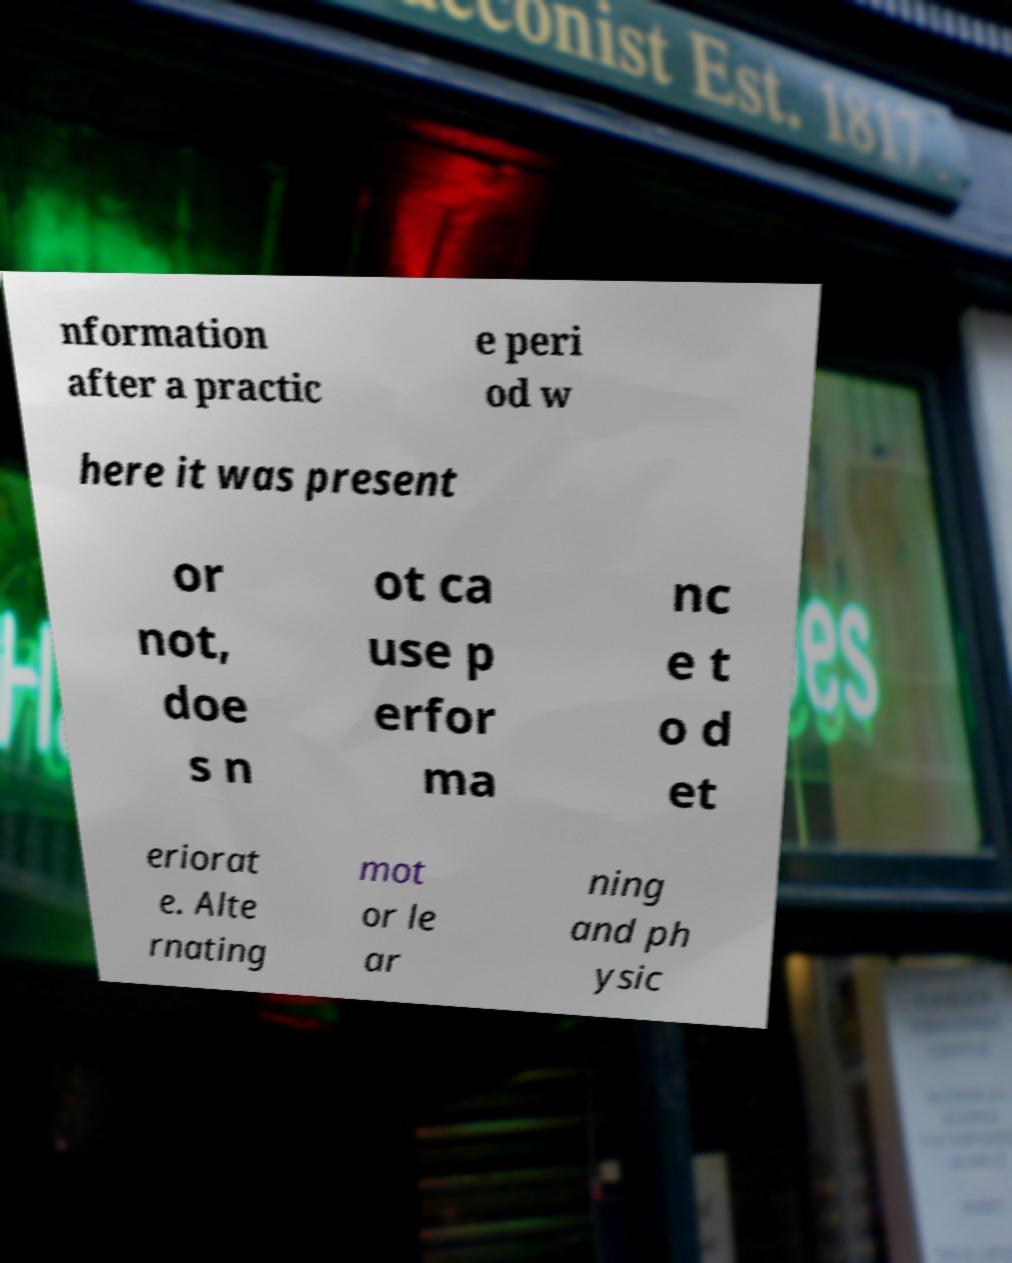I need the written content from this picture converted into text. Can you do that? nformation after a practic e peri od w here it was present or not, doe s n ot ca use p erfor ma nc e t o d et eriorat e. Alte rnating mot or le ar ning and ph ysic 